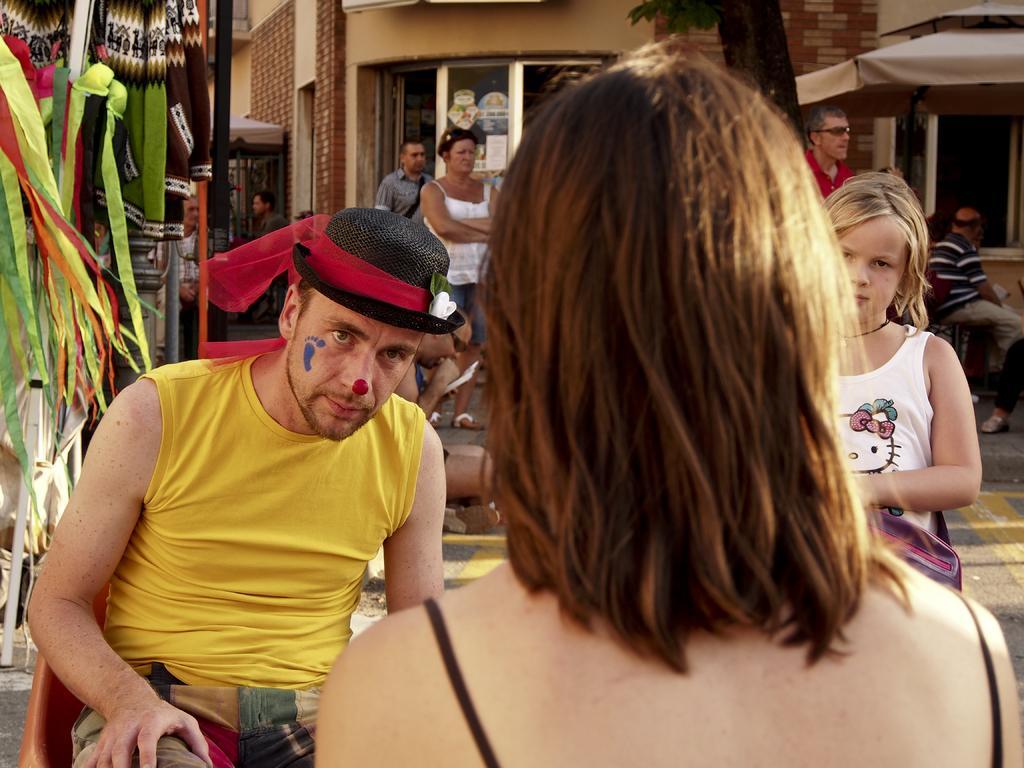How would you summarize this image in a sentence or two? In this image I can see number of people where few are sitting and few are standing. On the left side I can see one man is wearing a black colour hat. In the background I can see a building, a tree and on the left side I can see number of colourful things. 